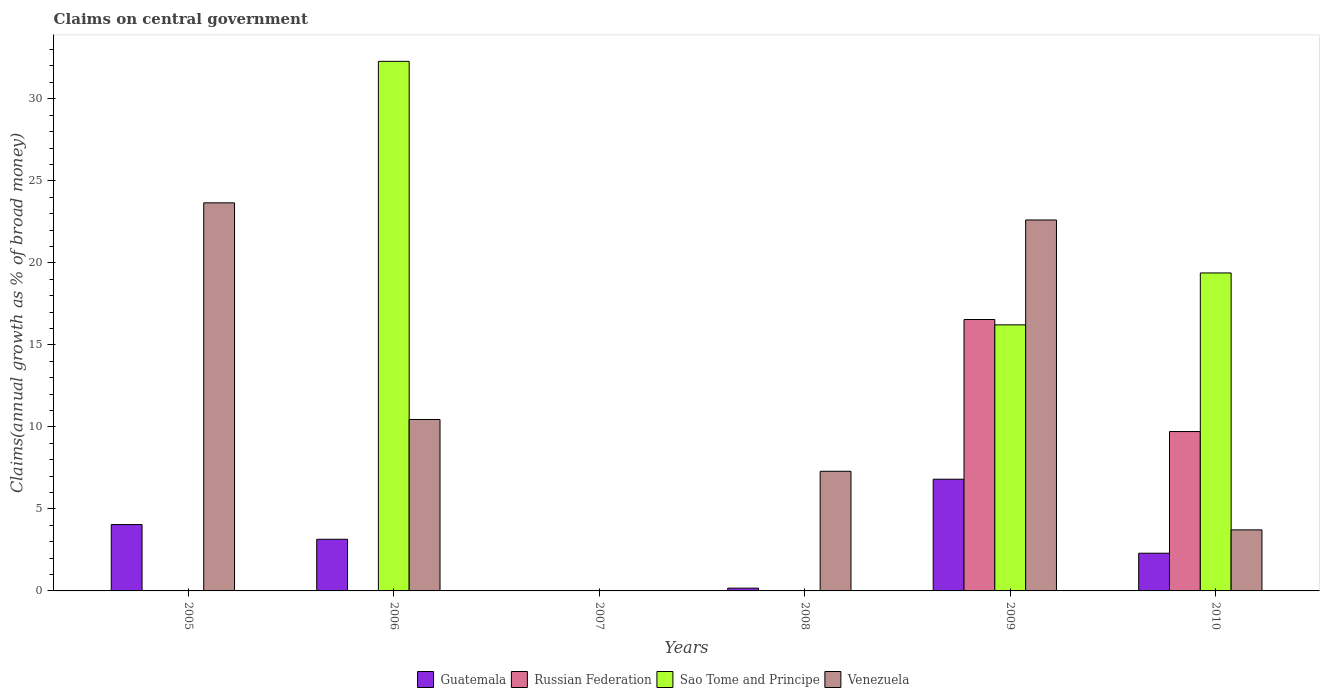How many different coloured bars are there?
Your answer should be very brief. 4. Are the number of bars per tick equal to the number of legend labels?
Offer a terse response. No. Are the number of bars on each tick of the X-axis equal?
Provide a short and direct response. No. How many bars are there on the 6th tick from the left?
Your answer should be compact. 4. How many bars are there on the 1st tick from the right?
Make the answer very short. 4. What is the percentage of broad money claimed on centeral government in Guatemala in 2010?
Offer a terse response. 2.3. Across all years, what is the maximum percentage of broad money claimed on centeral government in Venezuela?
Keep it short and to the point. 23.66. In which year was the percentage of broad money claimed on centeral government in Russian Federation maximum?
Provide a succinct answer. 2009. What is the total percentage of broad money claimed on centeral government in Guatemala in the graph?
Keep it short and to the point. 16.47. What is the difference between the percentage of broad money claimed on centeral government in Russian Federation in 2009 and that in 2010?
Offer a very short reply. 6.83. What is the difference between the percentage of broad money claimed on centeral government in Venezuela in 2008 and the percentage of broad money claimed on centeral government in Sao Tome and Principe in 2007?
Offer a very short reply. 7.29. What is the average percentage of broad money claimed on centeral government in Guatemala per year?
Your response must be concise. 2.75. In the year 2009, what is the difference between the percentage of broad money claimed on centeral government in Venezuela and percentage of broad money claimed on centeral government in Guatemala?
Ensure brevity in your answer.  15.8. In how many years, is the percentage of broad money claimed on centeral government in Venezuela greater than 8 %?
Your response must be concise. 3. What is the ratio of the percentage of broad money claimed on centeral government in Guatemala in 2006 to that in 2008?
Offer a very short reply. 18.64. Is the percentage of broad money claimed on centeral government in Venezuela in 2005 less than that in 2009?
Offer a very short reply. No. What is the difference between the highest and the second highest percentage of broad money claimed on centeral government in Guatemala?
Provide a short and direct response. 2.76. What is the difference between the highest and the lowest percentage of broad money claimed on centeral government in Sao Tome and Principe?
Make the answer very short. 32.28. In how many years, is the percentage of broad money claimed on centeral government in Sao Tome and Principe greater than the average percentage of broad money claimed on centeral government in Sao Tome and Principe taken over all years?
Offer a terse response. 3. Is it the case that in every year, the sum of the percentage of broad money claimed on centeral government in Venezuela and percentage of broad money claimed on centeral government in Russian Federation is greater than the percentage of broad money claimed on centeral government in Sao Tome and Principe?
Your response must be concise. No. Are the values on the major ticks of Y-axis written in scientific E-notation?
Your response must be concise. No. Does the graph contain any zero values?
Provide a short and direct response. Yes. How many legend labels are there?
Keep it short and to the point. 4. How are the legend labels stacked?
Give a very brief answer. Horizontal. What is the title of the graph?
Make the answer very short. Claims on central government. What is the label or title of the X-axis?
Your response must be concise. Years. What is the label or title of the Y-axis?
Provide a short and direct response. Claims(annual growth as % of broad money). What is the Claims(annual growth as % of broad money) in Guatemala in 2005?
Offer a very short reply. 4.05. What is the Claims(annual growth as % of broad money) in Sao Tome and Principe in 2005?
Make the answer very short. 0. What is the Claims(annual growth as % of broad money) of Venezuela in 2005?
Keep it short and to the point. 23.66. What is the Claims(annual growth as % of broad money) of Guatemala in 2006?
Provide a short and direct response. 3.15. What is the Claims(annual growth as % of broad money) in Sao Tome and Principe in 2006?
Make the answer very short. 32.28. What is the Claims(annual growth as % of broad money) of Venezuela in 2006?
Give a very brief answer. 10.45. What is the Claims(annual growth as % of broad money) of Guatemala in 2007?
Keep it short and to the point. 0. What is the Claims(annual growth as % of broad money) of Russian Federation in 2007?
Your answer should be compact. 0. What is the Claims(annual growth as % of broad money) of Venezuela in 2007?
Your answer should be very brief. 0. What is the Claims(annual growth as % of broad money) in Guatemala in 2008?
Provide a short and direct response. 0.17. What is the Claims(annual growth as % of broad money) of Venezuela in 2008?
Ensure brevity in your answer.  7.29. What is the Claims(annual growth as % of broad money) of Guatemala in 2009?
Your answer should be very brief. 6.81. What is the Claims(annual growth as % of broad money) of Russian Federation in 2009?
Offer a very short reply. 16.55. What is the Claims(annual growth as % of broad money) in Sao Tome and Principe in 2009?
Give a very brief answer. 16.22. What is the Claims(annual growth as % of broad money) in Venezuela in 2009?
Your answer should be very brief. 22.61. What is the Claims(annual growth as % of broad money) in Guatemala in 2010?
Make the answer very short. 2.3. What is the Claims(annual growth as % of broad money) in Russian Federation in 2010?
Offer a very short reply. 9.72. What is the Claims(annual growth as % of broad money) of Sao Tome and Principe in 2010?
Your answer should be very brief. 19.38. What is the Claims(annual growth as % of broad money) of Venezuela in 2010?
Give a very brief answer. 3.72. Across all years, what is the maximum Claims(annual growth as % of broad money) in Guatemala?
Ensure brevity in your answer.  6.81. Across all years, what is the maximum Claims(annual growth as % of broad money) of Russian Federation?
Your response must be concise. 16.55. Across all years, what is the maximum Claims(annual growth as % of broad money) of Sao Tome and Principe?
Ensure brevity in your answer.  32.28. Across all years, what is the maximum Claims(annual growth as % of broad money) of Venezuela?
Provide a succinct answer. 23.66. Across all years, what is the minimum Claims(annual growth as % of broad money) of Russian Federation?
Offer a terse response. 0. Across all years, what is the minimum Claims(annual growth as % of broad money) of Sao Tome and Principe?
Give a very brief answer. 0. What is the total Claims(annual growth as % of broad money) in Guatemala in the graph?
Provide a succinct answer. 16.47. What is the total Claims(annual growth as % of broad money) in Russian Federation in the graph?
Offer a very short reply. 26.26. What is the total Claims(annual growth as % of broad money) of Sao Tome and Principe in the graph?
Provide a succinct answer. 67.89. What is the total Claims(annual growth as % of broad money) in Venezuela in the graph?
Provide a short and direct response. 67.74. What is the difference between the Claims(annual growth as % of broad money) in Guatemala in 2005 and that in 2006?
Your answer should be compact. 0.9. What is the difference between the Claims(annual growth as % of broad money) in Venezuela in 2005 and that in 2006?
Your answer should be compact. 13.21. What is the difference between the Claims(annual growth as % of broad money) in Guatemala in 2005 and that in 2008?
Provide a succinct answer. 3.88. What is the difference between the Claims(annual growth as % of broad money) in Venezuela in 2005 and that in 2008?
Ensure brevity in your answer.  16.36. What is the difference between the Claims(annual growth as % of broad money) in Guatemala in 2005 and that in 2009?
Ensure brevity in your answer.  -2.76. What is the difference between the Claims(annual growth as % of broad money) in Venezuela in 2005 and that in 2009?
Give a very brief answer. 1.04. What is the difference between the Claims(annual growth as % of broad money) in Guatemala in 2005 and that in 2010?
Make the answer very short. 1.75. What is the difference between the Claims(annual growth as % of broad money) of Venezuela in 2005 and that in 2010?
Ensure brevity in your answer.  19.94. What is the difference between the Claims(annual growth as % of broad money) of Guatemala in 2006 and that in 2008?
Offer a very short reply. 2.98. What is the difference between the Claims(annual growth as % of broad money) in Venezuela in 2006 and that in 2008?
Ensure brevity in your answer.  3.16. What is the difference between the Claims(annual growth as % of broad money) in Guatemala in 2006 and that in 2009?
Make the answer very short. -3.66. What is the difference between the Claims(annual growth as % of broad money) of Sao Tome and Principe in 2006 and that in 2009?
Ensure brevity in your answer.  16.06. What is the difference between the Claims(annual growth as % of broad money) of Venezuela in 2006 and that in 2009?
Provide a succinct answer. -12.16. What is the difference between the Claims(annual growth as % of broad money) in Guatemala in 2006 and that in 2010?
Make the answer very short. 0.85. What is the difference between the Claims(annual growth as % of broad money) in Sao Tome and Principe in 2006 and that in 2010?
Provide a short and direct response. 12.9. What is the difference between the Claims(annual growth as % of broad money) in Venezuela in 2006 and that in 2010?
Keep it short and to the point. 6.73. What is the difference between the Claims(annual growth as % of broad money) in Guatemala in 2008 and that in 2009?
Offer a terse response. -6.64. What is the difference between the Claims(annual growth as % of broad money) in Venezuela in 2008 and that in 2009?
Your response must be concise. -15.32. What is the difference between the Claims(annual growth as % of broad money) in Guatemala in 2008 and that in 2010?
Your answer should be compact. -2.13. What is the difference between the Claims(annual growth as % of broad money) of Venezuela in 2008 and that in 2010?
Your answer should be compact. 3.57. What is the difference between the Claims(annual growth as % of broad money) of Guatemala in 2009 and that in 2010?
Offer a terse response. 4.51. What is the difference between the Claims(annual growth as % of broad money) of Russian Federation in 2009 and that in 2010?
Your answer should be very brief. 6.83. What is the difference between the Claims(annual growth as % of broad money) of Sao Tome and Principe in 2009 and that in 2010?
Your answer should be very brief. -3.16. What is the difference between the Claims(annual growth as % of broad money) of Venezuela in 2009 and that in 2010?
Your response must be concise. 18.89. What is the difference between the Claims(annual growth as % of broad money) of Guatemala in 2005 and the Claims(annual growth as % of broad money) of Sao Tome and Principe in 2006?
Offer a very short reply. -28.24. What is the difference between the Claims(annual growth as % of broad money) of Guatemala in 2005 and the Claims(annual growth as % of broad money) of Venezuela in 2006?
Your answer should be very brief. -6.41. What is the difference between the Claims(annual growth as % of broad money) of Guatemala in 2005 and the Claims(annual growth as % of broad money) of Venezuela in 2008?
Your answer should be very brief. -3.25. What is the difference between the Claims(annual growth as % of broad money) in Guatemala in 2005 and the Claims(annual growth as % of broad money) in Russian Federation in 2009?
Provide a succinct answer. -12.5. What is the difference between the Claims(annual growth as % of broad money) of Guatemala in 2005 and the Claims(annual growth as % of broad money) of Sao Tome and Principe in 2009?
Give a very brief answer. -12.17. What is the difference between the Claims(annual growth as % of broad money) of Guatemala in 2005 and the Claims(annual growth as % of broad money) of Venezuela in 2009?
Ensure brevity in your answer.  -18.57. What is the difference between the Claims(annual growth as % of broad money) in Guatemala in 2005 and the Claims(annual growth as % of broad money) in Russian Federation in 2010?
Provide a succinct answer. -5.67. What is the difference between the Claims(annual growth as % of broad money) in Guatemala in 2005 and the Claims(annual growth as % of broad money) in Sao Tome and Principe in 2010?
Offer a very short reply. -15.34. What is the difference between the Claims(annual growth as % of broad money) in Guatemala in 2005 and the Claims(annual growth as % of broad money) in Venezuela in 2010?
Make the answer very short. 0.32. What is the difference between the Claims(annual growth as % of broad money) of Guatemala in 2006 and the Claims(annual growth as % of broad money) of Venezuela in 2008?
Ensure brevity in your answer.  -4.14. What is the difference between the Claims(annual growth as % of broad money) in Sao Tome and Principe in 2006 and the Claims(annual growth as % of broad money) in Venezuela in 2008?
Keep it short and to the point. 24.99. What is the difference between the Claims(annual growth as % of broad money) of Guatemala in 2006 and the Claims(annual growth as % of broad money) of Russian Federation in 2009?
Offer a terse response. -13.4. What is the difference between the Claims(annual growth as % of broad money) of Guatemala in 2006 and the Claims(annual growth as % of broad money) of Sao Tome and Principe in 2009?
Offer a very short reply. -13.07. What is the difference between the Claims(annual growth as % of broad money) of Guatemala in 2006 and the Claims(annual growth as % of broad money) of Venezuela in 2009?
Provide a short and direct response. -19.46. What is the difference between the Claims(annual growth as % of broad money) of Sao Tome and Principe in 2006 and the Claims(annual growth as % of broad money) of Venezuela in 2009?
Offer a very short reply. 9.67. What is the difference between the Claims(annual growth as % of broad money) in Guatemala in 2006 and the Claims(annual growth as % of broad money) in Russian Federation in 2010?
Give a very brief answer. -6.57. What is the difference between the Claims(annual growth as % of broad money) of Guatemala in 2006 and the Claims(annual growth as % of broad money) of Sao Tome and Principe in 2010?
Give a very brief answer. -16.24. What is the difference between the Claims(annual growth as % of broad money) of Guatemala in 2006 and the Claims(annual growth as % of broad money) of Venezuela in 2010?
Offer a terse response. -0.57. What is the difference between the Claims(annual growth as % of broad money) in Sao Tome and Principe in 2006 and the Claims(annual growth as % of broad money) in Venezuela in 2010?
Give a very brief answer. 28.56. What is the difference between the Claims(annual growth as % of broad money) in Guatemala in 2008 and the Claims(annual growth as % of broad money) in Russian Federation in 2009?
Your answer should be compact. -16.38. What is the difference between the Claims(annual growth as % of broad money) in Guatemala in 2008 and the Claims(annual growth as % of broad money) in Sao Tome and Principe in 2009?
Offer a terse response. -16.05. What is the difference between the Claims(annual growth as % of broad money) of Guatemala in 2008 and the Claims(annual growth as % of broad money) of Venezuela in 2009?
Make the answer very short. -22.44. What is the difference between the Claims(annual growth as % of broad money) of Guatemala in 2008 and the Claims(annual growth as % of broad money) of Russian Federation in 2010?
Offer a terse response. -9.55. What is the difference between the Claims(annual growth as % of broad money) in Guatemala in 2008 and the Claims(annual growth as % of broad money) in Sao Tome and Principe in 2010?
Make the answer very short. -19.22. What is the difference between the Claims(annual growth as % of broad money) of Guatemala in 2008 and the Claims(annual growth as % of broad money) of Venezuela in 2010?
Make the answer very short. -3.55. What is the difference between the Claims(annual growth as % of broad money) of Guatemala in 2009 and the Claims(annual growth as % of broad money) of Russian Federation in 2010?
Keep it short and to the point. -2.91. What is the difference between the Claims(annual growth as % of broad money) of Guatemala in 2009 and the Claims(annual growth as % of broad money) of Sao Tome and Principe in 2010?
Your answer should be compact. -12.57. What is the difference between the Claims(annual growth as % of broad money) of Guatemala in 2009 and the Claims(annual growth as % of broad money) of Venezuela in 2010?
Keep it short and to the point. 3.09. What is the difference between the Claims(annual growth as % of broad money) of Russian Federation in 2009 and the Claims(annual growth as % of broad money) of Sao Tome and Principe in 2010?
Keep it short and to the point. -2.84. What is the difference between the Claims(annual growth as % of broad money) in Russian Federation in 2009 and the Claims(annual growth as % of broad money) in Venezuela in 2010?
Offer a very short reply. 12.82. What is the difference between the Claims(annual growth as % of broad money) of Sao Tome and Principe in 2009 and the Claims(annual growth as % of broad money) of Venezuela in 2010?
Offer a very short reply. 12.5. What is the average Claims(annual growth as % of broad money) of Guatemala per year?
Provide a succinct answer. 2.75. What is the average Claims(annual growth as % of broad money) of Russian Federation per year?
Give a very brief answer. 4.38. What is the average Claims(annual growth as % of broad money) in Sao Tome and Principe per year?
Provide a succinct answer. 11.31. What is the average Claims(annual growth as % of broad money) in Venezuela per year?
Provide a short and direct response. 11.29. In the year 2005, what is the difference between the Claims(annual growth as % of broad money) in Guatemala and Claims(annual growth as % of broad money) in Venezuela?
Your response must be concise. -19.61. In the year 2006, what is the difference between the Claims(annual growth as % of broad money) in Guatemala and Claims(annual growth as % of broad money) in Sao Tome and Principe?
Your answer should be very brief. -29.13. In the year 2006, what is the difference between the Claims(annual growth as % of broad money) in Guatemala and Claims(annual growth as % of broad money) in Venezuela?
Offer a very short reply. -7.3. In the year 2006, what is the difference between the Claims(annual growth as % of broad money) of Sao Tome and Principe and Claims(annual growth as % of broad money) of Venezuela?
Your answer should be compact. 21.83. In the year 2008, what is the difference between the Claims(annual growth as % of broad money) in Guatemala and Claims(annual growth as % of broad money) in Venezuela?
Give a very brief answer. -7.12. In the year 2009, what is the difference between the Claims(annual growth as % of broad money) of Guatemala and Claims(annual growth as % of broad money) of Russian Federation?
Give a very brief answer. -9.74. In the year 2009, what is the difference between the Claims(annual growth as % of broad money) in Guatemala and Claims(annual growth as % of broad money) in Sao Tome and Principe?
Your answer should be compact. -9.41. In the year 2009, what is the difference between the Claims(annual growth as % of broad money) in Guatemala and Claims(annual growth as % of broad money) in Venezuela?
Make the answer very short. -15.8. In the year 2009, what is the difference between the Claims(annual growth as % of broad money) in Russian Federation and Claims(annual growth as % of broad money) in Sao Tome and Principe?
Your answer should be compact. 0.33. In the year 2009, what is the difference between the Claims(annual growth as % of broad money) of Russian Federation and Claims(annual growth as % of broad money) of Venezuela?
Provide a succinct answer. -6.07. In the year 2009, what is the difference between the Claims(annual growth as % of broad money) of Sao Tome and Principe and Claims(annual growth as % of broad money) of Venezuela?
Your answer should be compact. -6.39. In the year 2010, what is the difference between the Claims(annual growth as % of broad money) of Guatemala and Claims(annual growth as % of broad money) of Russian Federation?
Your answer should be very brief. -7.42. In the year 2010, what is the difference between the Claims(annual growth as % of broad money) in Guatemala and Claims(annual growth as % of broad money) in Sao Tome and Principe?
Ensure brevity in your answer.  -17.09. In the year 2010, what is the difference between the Claims(annual growth as % of broad money) in Guatemala and Claims(annual growth as % of broad money) in Venezuela?
Provide a short and direct response. -1.42. In the year 2010, what is the difference between the Claims(annual growth as % of broad money) in Russian Federation and Claims(annual growth as % of broad money) in Sao Tome and Principe?
Your answer should be compact. -9.67. In the year 2010, what is the difference between the Claims(annual growth as % of broad money) of Russian Federation and Claims(annual growth as % of broad money) of Venezuela?
Make the answer very short. 5.99. In the year 2010, what is the difference between the Claims(annual growth as % of broad money) in Sao Tome and Principe and Claims(annual growth as % of broad money) in Venezuela?
Offer a terse response. 15.66. What is the ratio of the Claims(annual growth as % of broad money) in Guatemala in 2005 to that in 2006?
Provide a short and direct response. 1.28. What is the ratio of the Claims(annual growth as % of broad money) of Venezuela in 2005 to that in 2006?
Your response must be concise. 2.26. What is the ratio of the Claims(annual growth as % of broad money) in Guatemala in 2005 to that in 2008?
Give a very brief answer. 23.95. What is the ratio of the Claims(annual growth as % of broad money) of Venezuela in 2005 to that in 2008?
Keep it short and to the point. 3.24. What is the ratio of the Claims(annual growth as % of broad money) in Guatemala in 2005 to that in 2009?
Your response must be concise. 0.59. What is the ratio of the Claims(annual growth as % of broad money) in Venezuela in 2005 to that in 2009?
Offer a very short reply. 1.05. What is the ratio of the Claims(annual growth as % of broad money) of Guatemala in 2005 to that in 2010?
Provide a short and direct response. 1.76. What is the ratio of the Claims(annual growth as % of broad money) of Venezuela in 2005 to that in 2010?
Give a very brief answer. 6.36. What is the ratio of the Claims(annual growth as % of broad money) in Guatemala in 2006 to that in 2008?
Your answer should be very brief. 18.64. What is the ratio of the Claims(annual growth as % of broad money) of Venezuela in 2006 to that in 2008?
Your answer should be very brief. 1.43. What is the ratio of the Claims(annual growth as % of broad money) of Guatemala in 2006 to that in 2009?
Ensure brevity in your answer.  0.46. What is the ratio of the Claims(annual growth as % of broad money) in Sao Tome and Principe in 2006 to that in 2009?
Your response must be concise. 1.99. What is the ratio of the Claims(annual growth as % of broad money) of Venezuela in 2006 to that in 2009?
Keep it short and to the point. 0.46. What is the ratio of the Claims(annual growth as % of broad money) in Guatemala in 2006 to that in 2010?
Provide a short and direct response. 1.37. What is the ratio of the Claims(annual growth as % of broad money) in Sao Tome and Principe in 2006 to that in 2010?
Provide a short and direct response. 1.67. What is the ratio of the Claims(annual growth as % of broad money) in Venezuela in 2006 to that in 2010?
Ensure brevity in your answer.  2.81. What is the ratio of the Claims(annual growth as % of broad money) of Guatemala in 2008 to that in 2009?
Make the answer very short. 0.02. What is the ratio of the Claims(annual growth as % of broad money) of Venezuela in 2008 to that in 2009?
Offer a very short reply. 0.32. What is the ratio of the Claims(annual growth as % of broad money) of Guatemala in 2008 to that in 2010?
Keep it short and to the point. 0.07. What is the ratio of the Claims(annual growth as % of broad money) of Venezuela in 2008 to that in 2010?
Provide a short and direct response. 1.96. What is the ratio of the Claims(annual growth as % of broad money) in Guatemala in 2009 to that in 2010?
Provide a succinct answer. 2.96. What is the ratio of the Claims(annual growth as % of broad money) in Russian Federation in 2009 to that in 2010?
Make the answer very short. 1.7. What is the ratio of the Claims(annual growth as % of broad money) in Sao Tome and Principe in 2009 to that in 2010?
Offer a very short reply. 0.84. What is the ratio of the Claims(annual growth as % of broad money) in Venezuela in 2009 to that in 2010?
Your answer should be very brief. 6.08. What is the difference between the highest and the second highest Claims(annual growth as % of broad money) in Guatemala?
Give a very brief answer. 2.76. What is the difference between the highest and the second highest Claims(annual growth as % of broad money) in Sao Tome and Principe?
Your answer should be compact. 12.9. What is the difference between the highest and the second highest Claims(annual growth as % of broad money) in Venezuela?
Your answer should be compact. 1.04. What is the difference between the highest and the lowest Claims(annual growth as % of broad money) of Guatemala?
Keep it short and to the point. 6.81. What is the difference between the highest and the lowest Claims(annual growth as % of broad money) in Russian Federation?
Your response must be concise. 16.55. What is the difference between the highest and the lowest Claims(annual growth as % of broad money) of Sao Tome and Principe?
Your response must be concise. 32.28. What is the difference between the highest and the lowest Claims(annual growth as % of broad money) of Venezuela?
Your answer should be very brief. 23.66. 